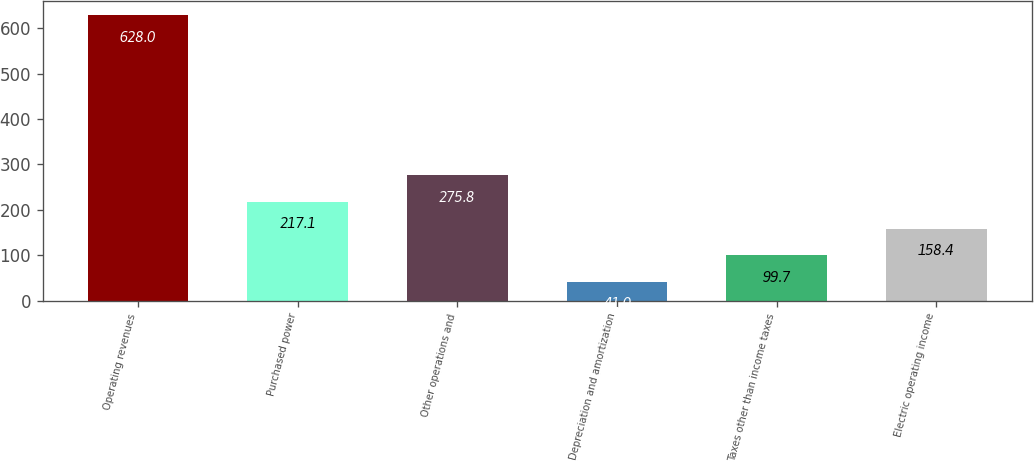Convert chart. <chart><loc_0><loc_0><loc_500><loc_500><bar_chart><fcel>Operating revenues<fcel>Purchased power<fcel>Other operations and<fcel>Depreciation and amortization<fcel>Taxes other than income taxes<fcel>Electric operating income<nl><fcel>628<fcel>217.1<fcel>275.8<fcel>41<fcel>99.7<fcel>158.4<nl></chart> 